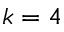Convert formula to latex. <formula><loc_0><loc_0><loc_500><loc_500>k = 4</formula> 